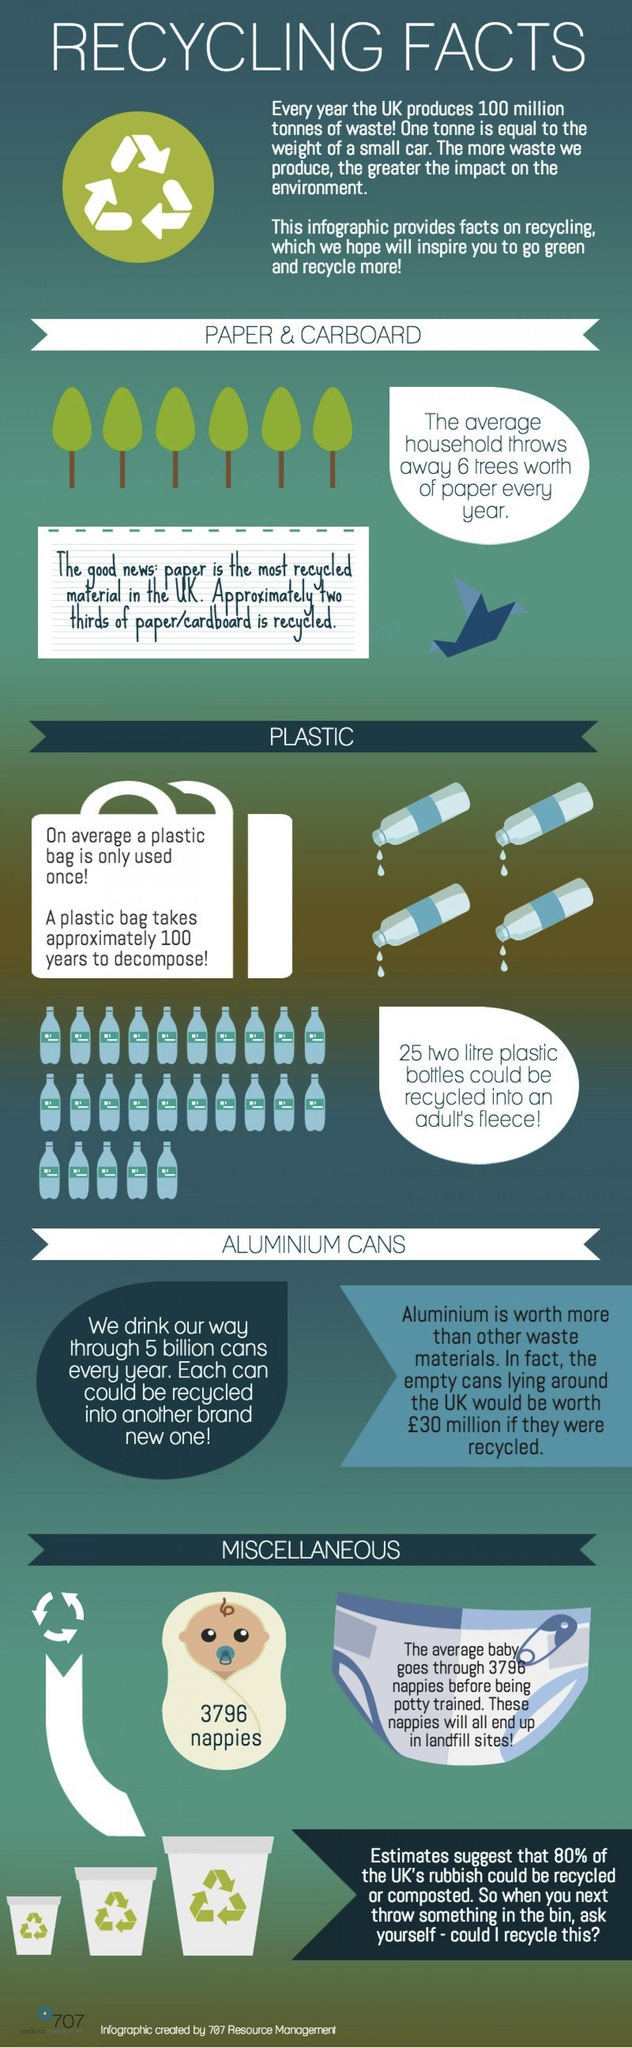Point out several critical features in this image. There are a total of three recycle bins present in this area. Plastic bags take a century to decompose, making them a harmful and long-lasting product that pollutes the environment. In the UK, paper is the most recycled material, surpassing plastic and aluminum cans. The image shows a total of six trees. The written content on the image of the baby is 3796 nappies. 